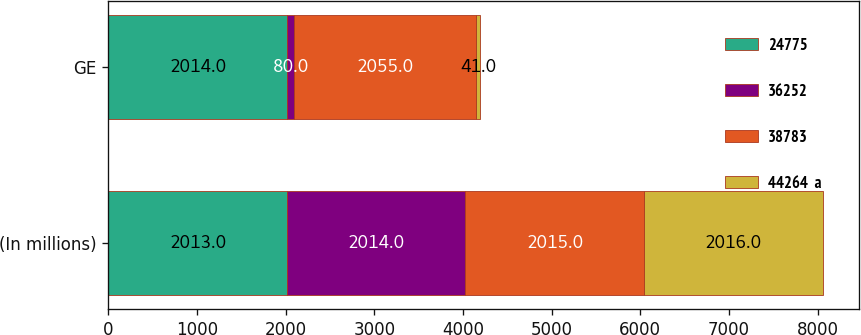Convert chart. <chart><loc_0><loc_0><loc_500><loc_500><stacked_bar_chart><ecel><fcel>(In millions)<fcel>GE<nl><fcel>24775<fcel>2013<fcel>2014<nl><fcel>36252<fcel>2014<fcel>80<nl><fcel>38783<fcel>2015<fcel>2055<nl><fcel>44264  a<fcel>2016<fcel>41<nl></chart> 